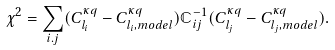Convert formula to latex. <formula><loc_0><loc_0><loc_500><loc_500>\chi ^ { 2 } = \sum _ { i . j } ( C _ { l _ { i } } ^ { \kappa q } - C _ { l _ { i } , m o d e l } ^ { \kappa q } ) \mathbb { C } _ { i j } ^ { - 1 } ( C _ { l _ { j } } ^ { \kappa q } - C _ { l _ { j } , m o d e l } ^ { \kappa q } ) .</formula> 